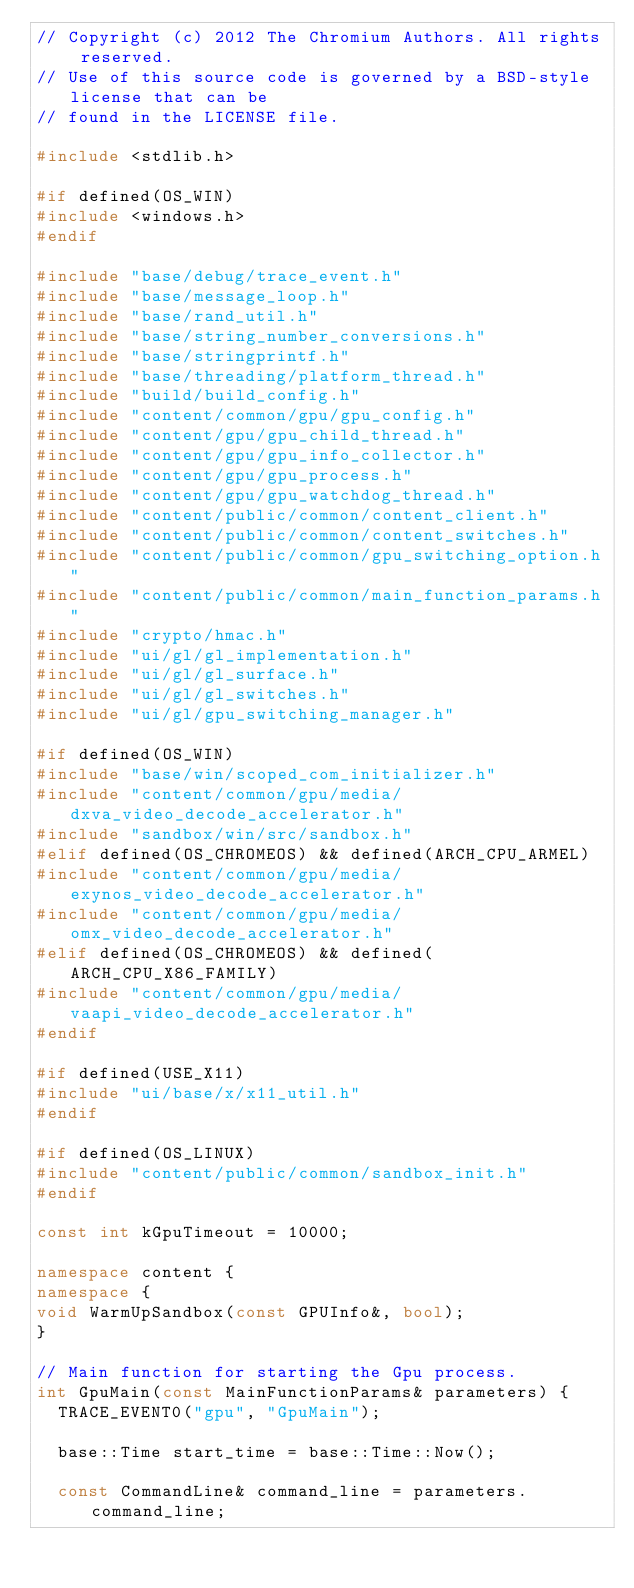Convert code to text. <code><loc_0><loc_0><loc_500><loc_500><_C++_>// Copyright (c) 2012 The Chromium Authors. All rights reserved.
// Use of this source code is governed by a BSD-style license that can be
// found in the LICENSE file.

#include <stdlib.h>

#if defined(OS_WIN)
#include <windows.h>
#endif

#include "base/debug/trace_event.h"
#include "base/message_loop.h"
#include "base/rand_util.h"
#include "base/string_number_conversions.h"
#include "base/stringprintf.h"
#include "base/threading/platform_thread.h"
#include "build/build_config.h"
#include "content/common/gpu/gpu_config.h"
#include "content/gpu/gpu_child_thread.h"
#include "content/gpu/gpu_info_collector.h"
#include "content/gpu/gpu_process.h"
#include "content/gpu/gpu_watchdog_thread.h"
#include "content/public/common/content_client.h"
#include "content/public/common/content_switches.h"
#include "content/public/common/gpu_switching_option.h"
#include "content/public/common/main_function_params.h"
#include "crypto/hmac.h"
#include "ui/gl/gl_implementation.h"
#include "ui/gl/gl_surface.h"
#include "ui/gl/gl_switches.h"
#include "ui/gl/gpu_switching_manager.h"

#if defined(OS_WIN)
#include "base/win/scoped_com_initializer.h"
#include "content/common/gpu/media/dxva_video_decode_accelerator.h"
#include "sandbox/win/src/sandbox.h"
#elif defined(OS_CHROMEOS) && defined(ARCH_CPU_ARMEL)
#include "content/common/gpu/media/exynos_video_decode_accelerator.h"
#include "content/common/gpu/media/omx_video_decode_accelerator.h"
#elif defined(OS_CHROMEOS) && defined(ARCH_CPU_X86_FAMILY)
#include "content/common/gpu/media/vaapi_video_decode_accelerator.h"
#endif

#if defined(USE_X11)
#include "ui/base/x/x11_util.h"
#endif

#if defined(OS_LINUX)
#include "content/public/common/sandbox_init.h"
#endif

const int kGpuTimeout = 10000;

namespace content {
namespace {
void WarmUpSandbox(const GPUInfo&, bool);
}

// Main function for starting the Gpu process.
int GpuMain(const MainFunctionParams& parameters) {
  TRACE_EVENT0("gpu", "GpuMain");

  base::Time start_time = base::Time::Now();

  const CommandLine& command_line = parameters.command_line;</code> 